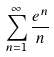Convert formula to latex. <formula><loc_0><loc_0><loc_500><loc_500>\sum _ { n = 1 } ^ { \infty } \frac { e ^ { n } } { n }</formula> 